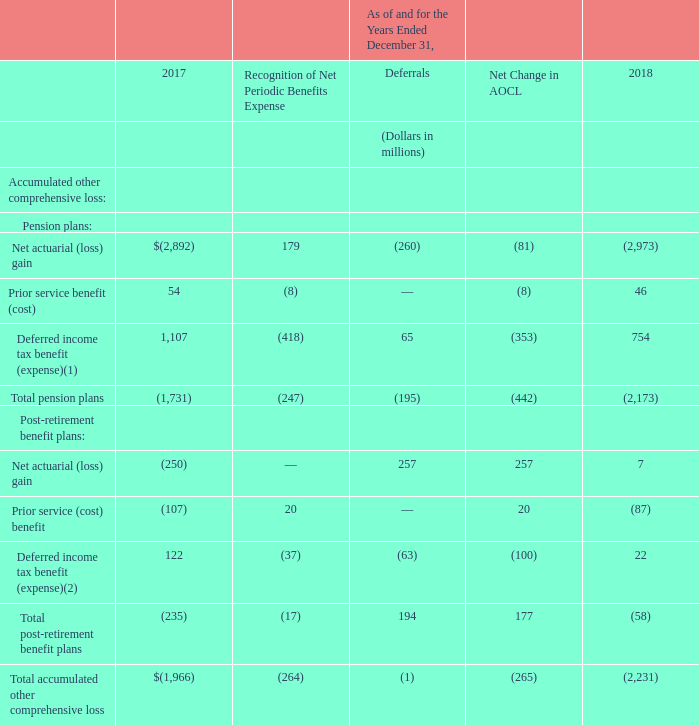The following table presents cumulative items not recognized as a component of net periodic benefits expense as of December 31, 2017, items recognized as a component of net periodic benefits expense in 2018, additional items deferred during 2018 and cumulative items not recognized as a component of net periodic benefits expense as of December 31, 2017. The items not recognized as a component of net periodic benefits expense have been recorded on our consolidated balance sheets in accumulated other comprehensive loss:
(1) Amounts currently recognized in net periodic benefits expense include $375 million of benefit arising from the adoption of ASU 2018-02. See Note 1— Background and Summary of Significant Accounting Policies for further detail.
(2) Amounts currently recognized in net periodic benefits expense include $32 million arising from the adoption of ASU 2018-02. See Note 1— Background and Summary of Significant Accounting Policies for further detail.
What does the deferred income tax benefit (expense) under pension plans currently recognize?  Amounts currently recognized in net periodic benefits expense include $375 million of benefit arising from the adoption of asu 2018-02. What does the deferred income tax benefit (expense) under post-retirement benefit plans currently recognize?  Amounts currently recognized in net periodic benefits expense include $32 million arising from the adoption of asu 2018-02. What does the table show? Presents cumulative items not recognized as a component of net periodic benefits expense as of december 31, 2017, items recognized as a component of net periodic benefits expense in 2018, additional items deferred during 2018 and cumulative items not recognized as a component of net periodic benefits expense as of december 31, 2017. In which year is the prior service benefit (cost) for pension plans larger? 54>46
Answer: 2017. What is the sum of the prior service benefit (cost) for pension plans in 2017 and 2018?
Answer scale should be: million. 54+46
Answer: 100. What is the percentage change in the deferred income tax benefit (expense) for post-retirement benefit plans in 2018 from 2017?
Answer scale should be: percent. (22-122)/122
Answer: -81.97. 